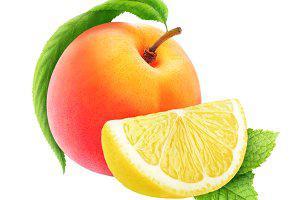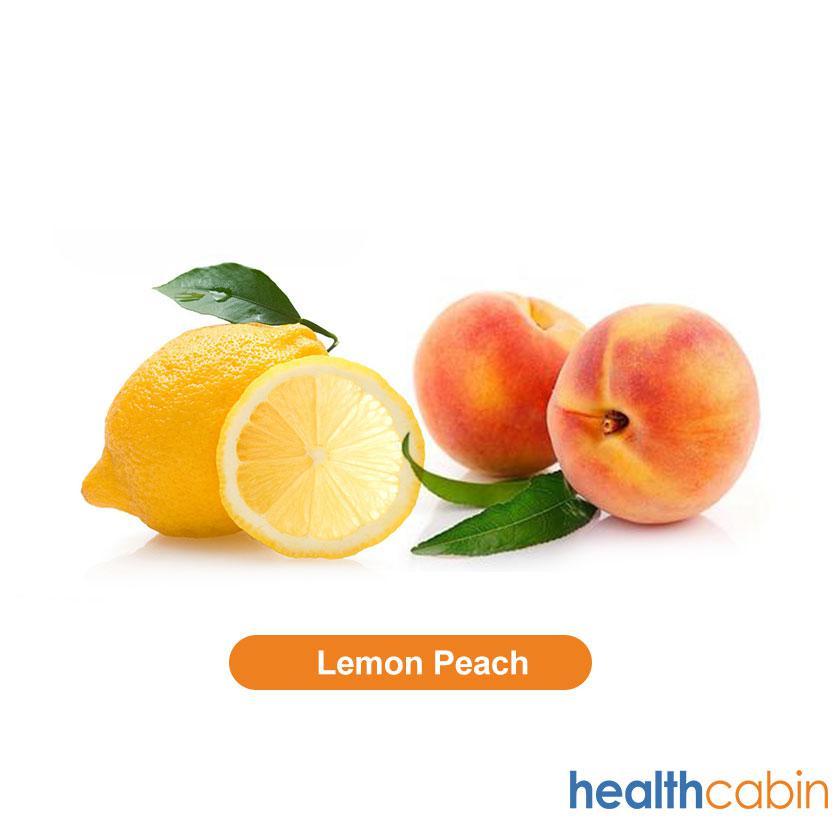The first image is the image on the left, the second image is the image on the right. Evaluate the accuracy of this statement regarding the images: "An image contains two intact peaches, plus a whole lemon next to part of a lemon.". Is it true? Answer yes or no. Yes. 